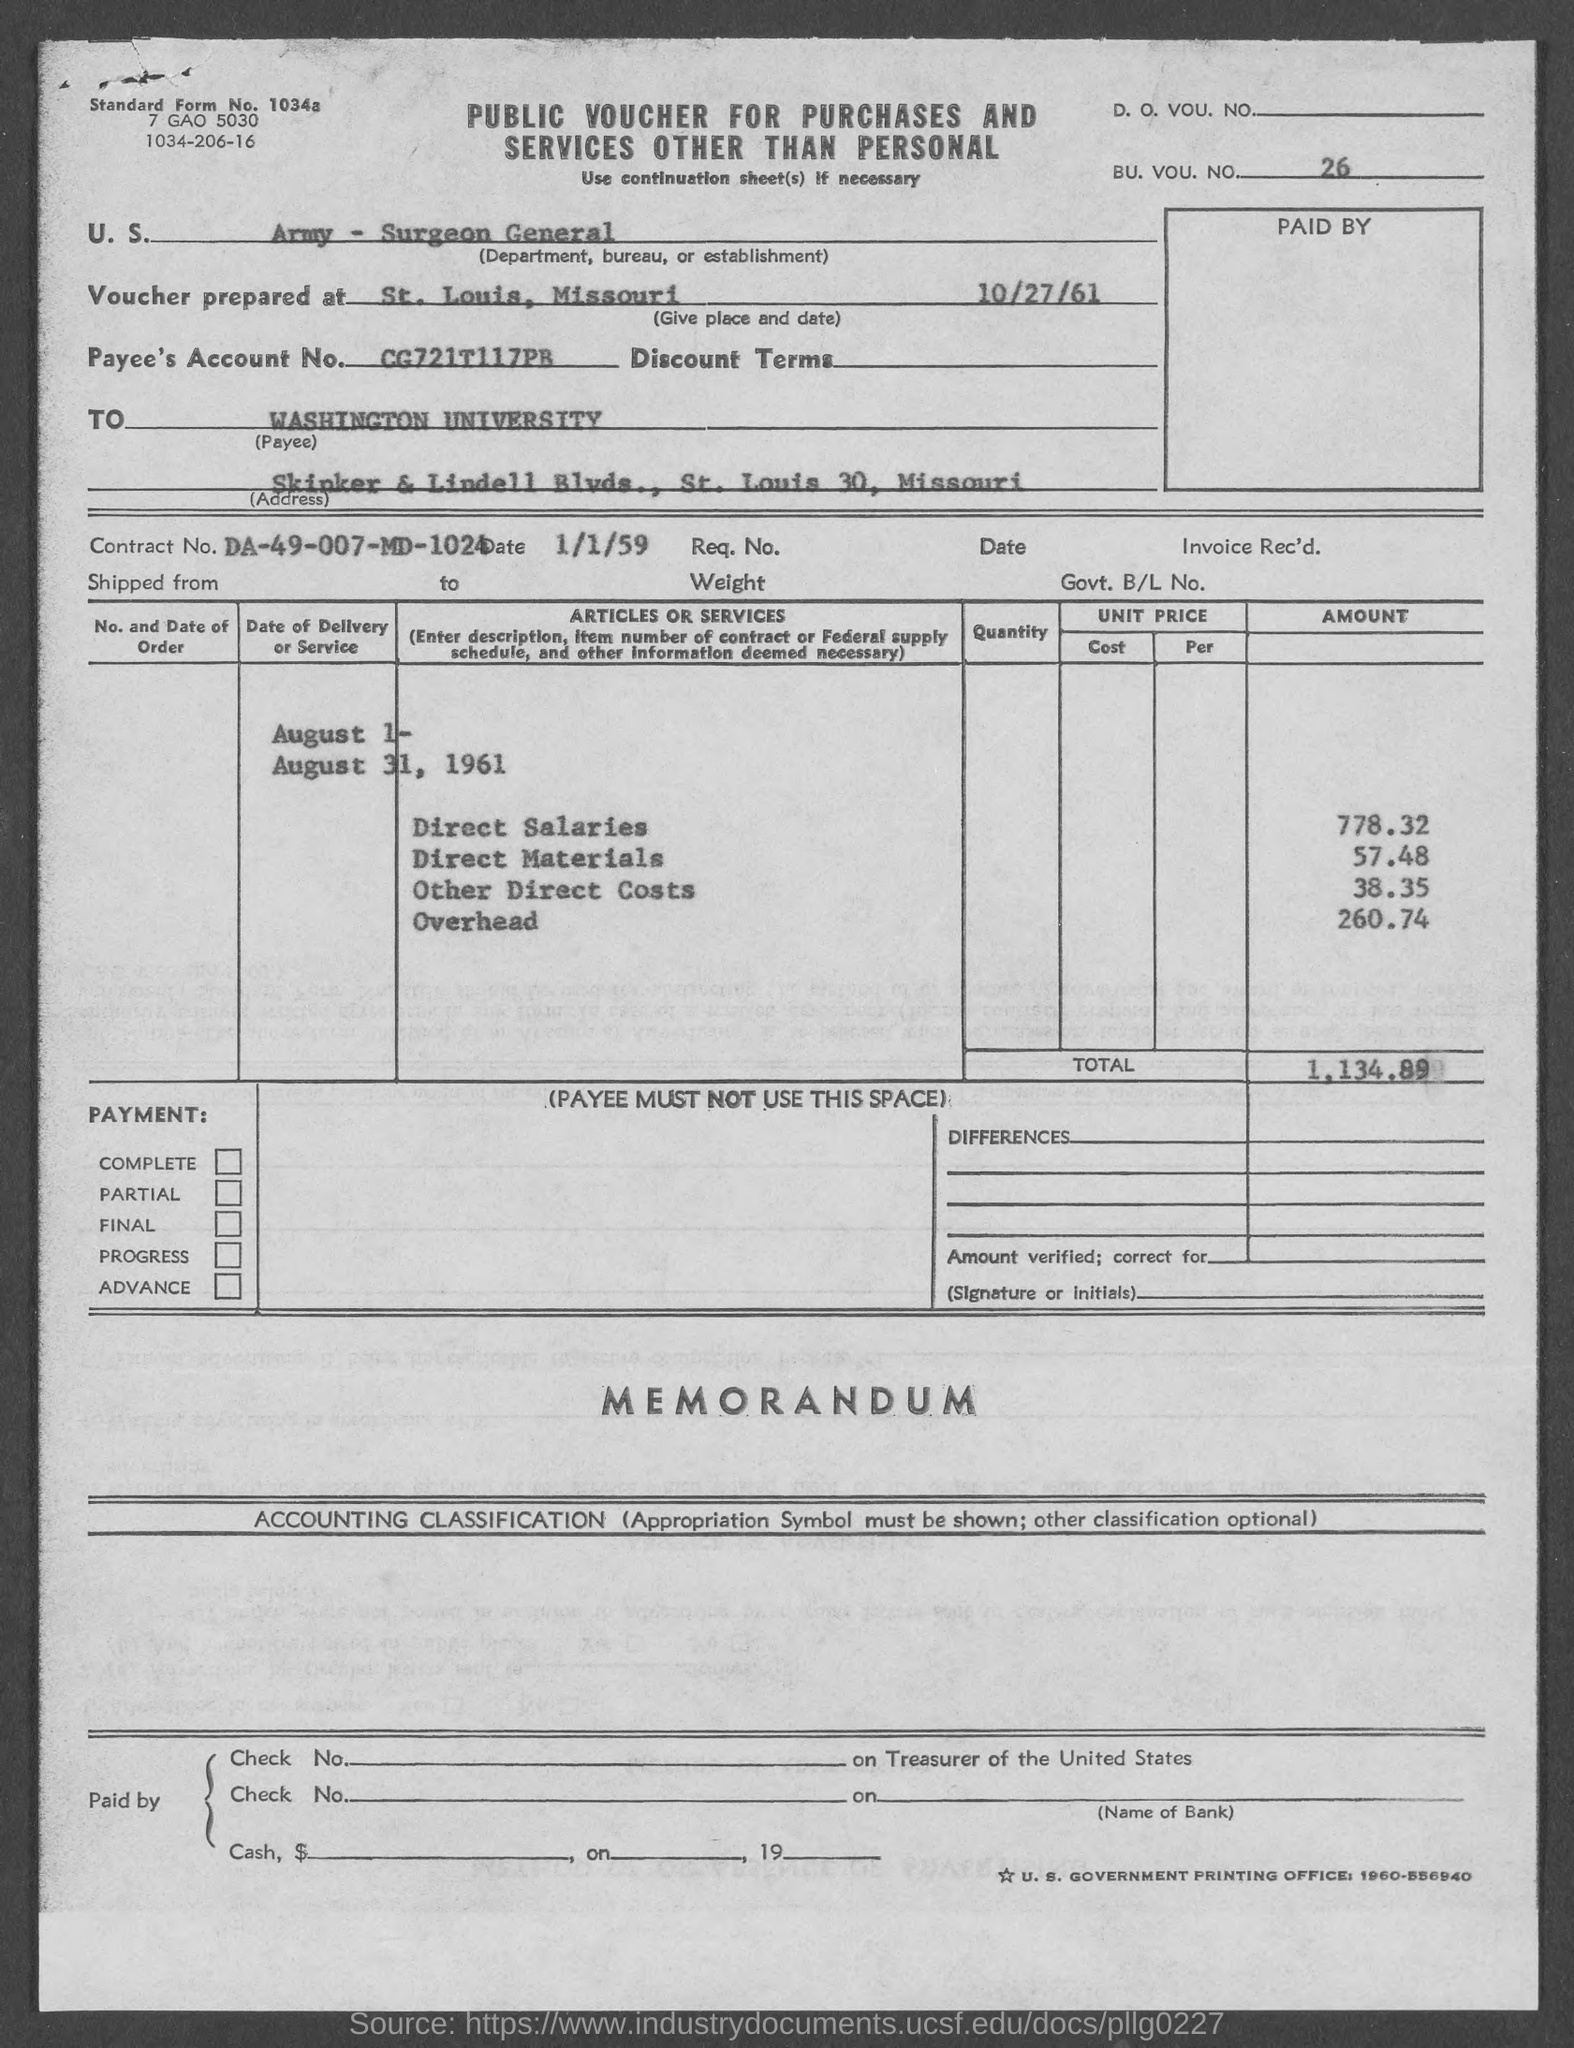Give some essential details in this illustration. The amount of other direct costs is 38.35. The amount of direct salaries is 778.32. The contract number is DA-49-007-MD-1024. Washington University is located in the state of Missouri. The amount of Direct Materials is 57.48. 